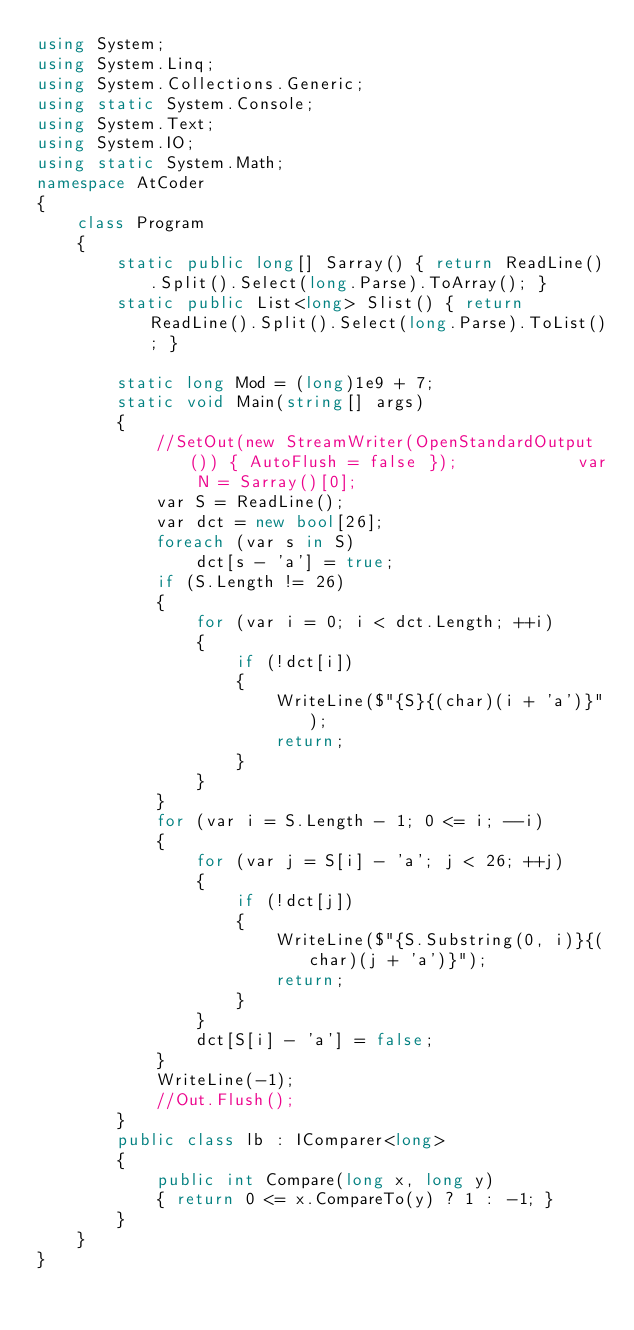<code> <loc_0><loc_0><loc_500><loc_500><_C#_>using System;
using System.Linq;
using System.Collections.Generic;
using static System.Console;
using System.Text;
using System.IO;
using static System.Math;
namespace AtCoder
{
    class Program
    {
        static public long[] Sarray() { return ReadLine().Split().Select(long.Parse).ToArray(); }
        static public List<long> Slist() { return ReadLine().Split().Select(long.Parse).ToList(); }

        static long Mod = (long)1e9 + 7;
        static void Main(string[] args)
        {
            //SetOut(new StreamWriter(OpenStandardOutput()) { AutoFlush = false });            var N = Sarray()[0];
            var S = ReadLine();
            var dct = new bool[26];
            foreach (var s in S)
                dct[s - 'a'] = true;
            if (S.Length != 26)
            {
                for (var i = 0; i < dct.Length; ++i)
                {
                    if (!dct[i])
                    {
                        WriteLine($"{S}{(char)(i + 'a')}");
                        return;
                    }
                }
            }
            for (var i = S.Length - 1; 0 <= i; --i)
            {
                for (var j = S[i] - 'a'; j < 26; ++j) 
                {
                    if (!dct[j])
                    {
                        WriteLine($"{S.Substring(0, i)}{(char)(j + 'a')}");
                        return;
                    }
                }
                dct[S[i] - 'a'] = false;
            }
            WriteLine(-1);
            //Out.Flush();
        }
        public class lb : IComparer<long>
        {
            public int Compare(long x, long y)
            { return 0 <= x.CompareTo(y) ? 1 : -1; }
        }
    }
}</code> 